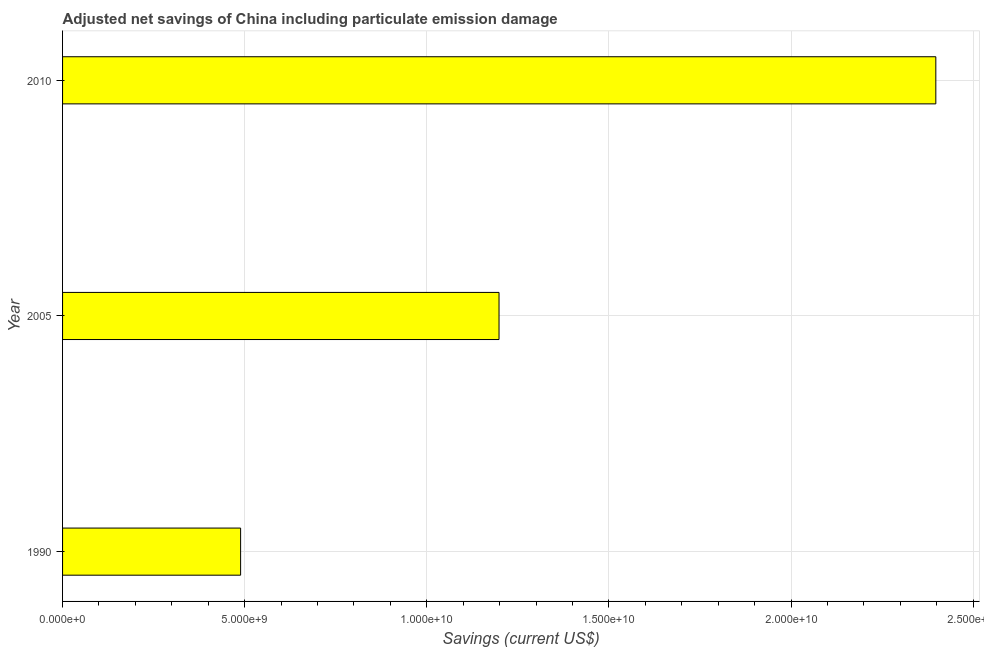Does the graph contain grids?
Offer a terse response. Yes. What is the title of the graph?
Your answer should be very brief. Adjusted net savings of China including particulate emission damage. What is the label or title of the X-axis?
Offer a terse response. Savings (current US$). What is the adjusted net savings in 2005?
Offer a terse response. 1.20e+1. Across all years, what is the maximum adjusted net savings?
Offer a very short reply. 2.40e+1. Across all years, what is the minimum adjusted net savings?
Give a very brief answer. 4.89e+09. In which year was the adjusted net savings maximum?
Your answer should be very brief. 2010. What is the sum of the adjusted net savings?
Your answer should be very brief. 4.08e+1. What is the difference between the adjusted net savings in 1990 and 2005?
Your answer should be compact. -7.09e+09. What is the average adjusted net savings per year?
Your answer should be very brief. 1.36e+1. What is the median adjusted net savings?
Provide a succinct answer. 1.20e+1. In how many years, is the adjusted net savings greater than 23000000000 US$?
Provide a succinct answer. 1. What is the ratio of the adjusted net savings in 1990 to that in 2005?
Keep it short and to the point. 0.41. Is the adjusted net savings in 1990 less than that in 2010?
Offer a very short reply. Yes. What is the difference between the highest and the second highest adjusted net savings?
Ensure brevity in your answer.  1.20e+1. Is the sum of the adjusted net savings in 1990 and 2010 greater than the maximum adjusted net savings across all years?
Give a very brief answer. Yes. What is the difference between the highest and the lowest adjusted net savings?
Provide a succinct answer. 1.91e+1. How many bars are there?
Offer a terse response. 3. How many years are there in the graph?
Offer a very short reply. 3. Are the values on the major ticks of X-axis written in scientific E-notation?
Provide a succinct answer. Yes. What is the Savings (current US$) of 1990?
Provide a succinct answer. 4.89e+09. What is the Savings (current US$) in 2005?
Give a very brief answer. 1.20e+1. What is the Savings (current US$) of 2010?
Offer a terse response. 2.40e+1. What is the difference between the Savings (current US$) in 1990 and 2005?
Keep it short and to the point. -7.09e+09. What is the difference between the Savings (current US$) in 1990 and 2010?
Offer a terse response. -1.91e+1. What is the difference between the Savings (current US$) in 2005 and 2010?
Your response must be concise. -1.20e+1. What is the ratio of the Savings (current US$) in 1990 to that in 2005?
Offer a very short reply. 0.41. What is the ratio of the Savings (current US$) in 1990 to that in 2010?
Your answer should be compact. 0.2. What is the ratio of the Savings (current US$) in 2005 to that in 2010?
Your response must be concise. 0.5. 